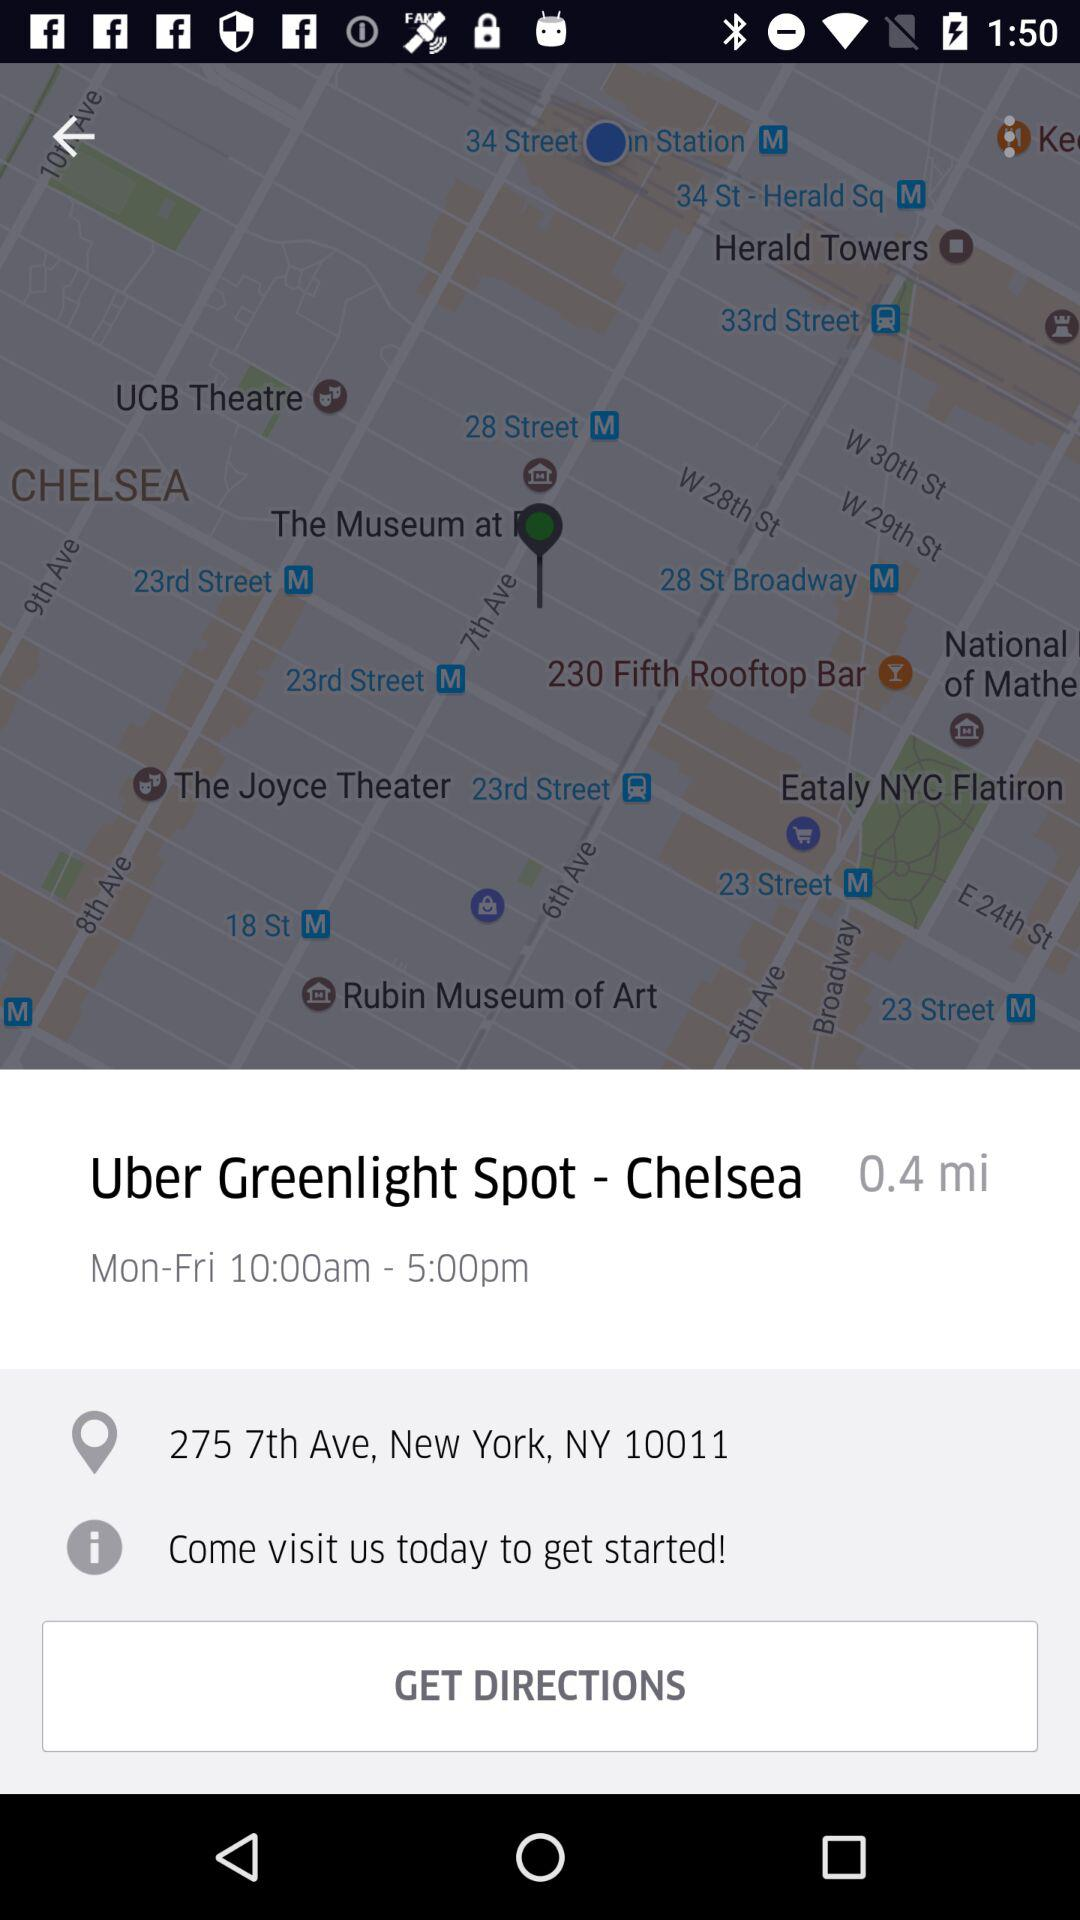What are the timings? The timings are Mon-Fri, 10:00 am-5:00 pm. 